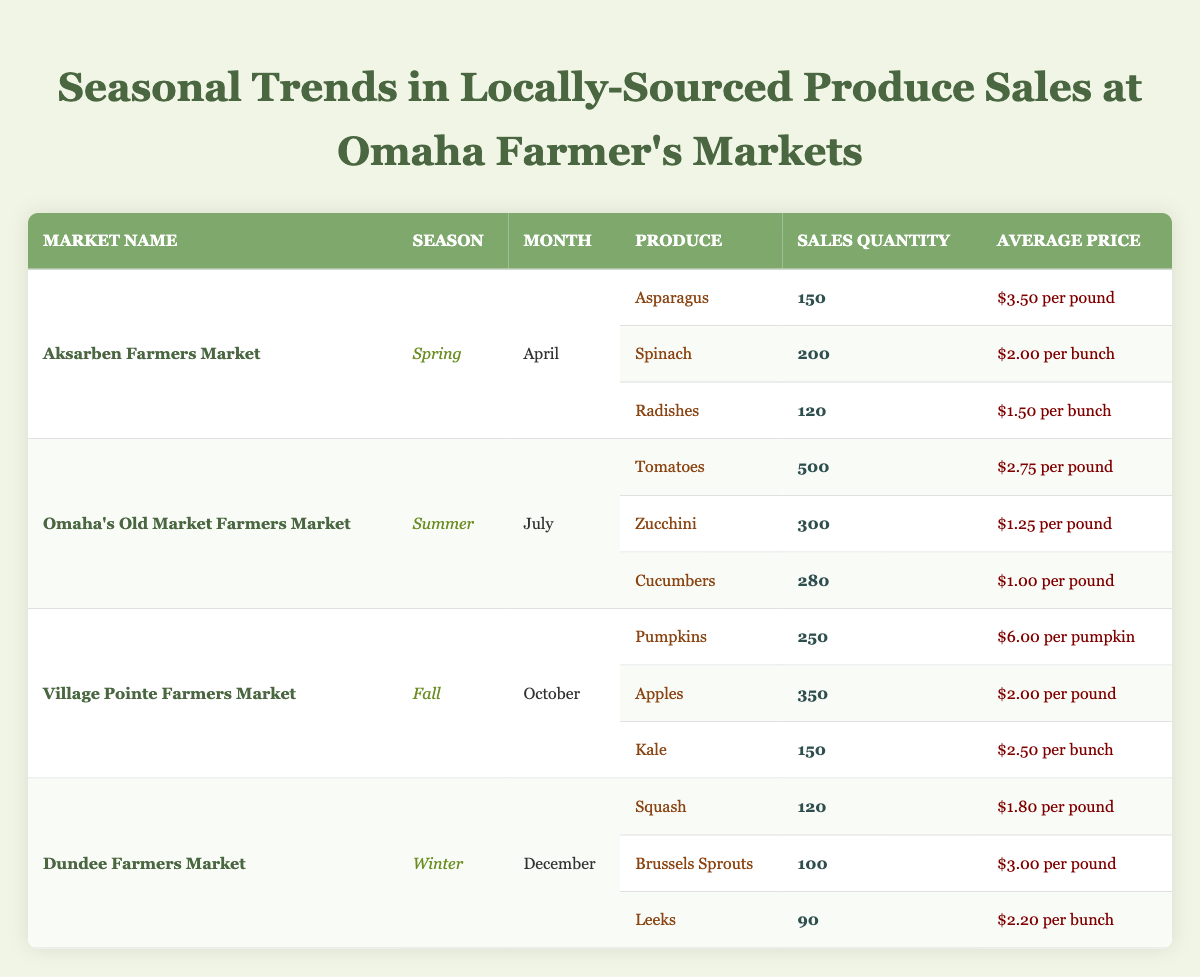What produce sold the most quantity at the Aksarben Farmers Market? Referring to the Aksarben Farmers Market row, the produce sold with the highest quantity is Spinach, with 200 sold.
Answer: Spinach Which market had the highest total sales quantity in the Summer season? At Omaha's Old Market Farmers Market in July, the quantity sold is: Tomatoes (500) + Zucchini (300) + Cucumbers (280) = 1080. This is the only market in the Summer season.
Answer: 1080 What is the average sales quantity of produce sold in the Fall season? At Village Pointe Farmers Market in October, the sales quantities are Pumpkins (250), Apples (350), and Kale (150). The total is 250 + 350 + 150 = 750. The average is 750/3 = 250.
Answer: 250 Did the Aksarben Farmers Market sell any produce at a price of $2.00 or lower? In the Aksarben Farmers Market, the prices are $3.50 for Asparagus, $2.00 for Spinach, and $1.50 for Radishes. Since Spinach and Radishes are $2.00 and below, the statement is true.
Answer: Yes What is the total sales quantity for pumpkins and apples at the Village Pointe Farmers Market? At Village Pointe Farmers Market, the sales quantity for Pumpkins is 250 and for Apples is 350. Adding these gives a total of 250 + 350 = 600.
Answer: 600 Which market had the highest average price per item sold? To find the average prices: Aksarben Farmers Market (3.50, 2.00, 1.50), Omaha's Old Market Farmers Market (2.75, 1.25, 1.00), Village Pointe Farmers Market (6.00, 2.00, 2.50), and Dundee Farmers Market (1.80, 3.00, 2.20). The highest average price is at Village Pointe Farmers Market ($6.00).
Answer: Village Pointe Farmers Market How many more pounds of tomatoes were sold compared to cucumbers at the Omaha's Old Market Farmers Market? In the Omaha's Old Market Farmers Market, tomatoes sold 500 pounds, and cucumbers sold 280 pounds. The difference is 500 - 280 = 220.
Answer: 220 Was the total sales quantity of produce higher in Spring or Winter? The total for Spring (Aksarben Farmers Market) is 150 (Asparagus) + 200 (Spinach) + 120 (Radishes) = 470. For Winter (Dundee Farmers Market), the total is 120 (Squash) + 100 (Brussels Sprouts) + 90 (Leeks) = 310. Since 470 > 310, Spring had higher sales.
Answer: Spring What are the names of all the produce sold in the Winter season? In the Winter season at Dundee Farmers Market, the produce sold includes Squash, Brussels Sprouts, and Leeks.
Answer: Squash, Brussels Sprouts, Leeks 